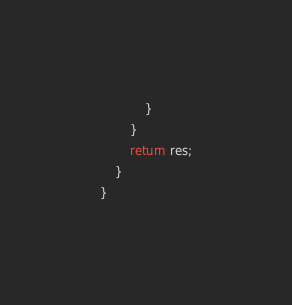Convert code to text. <code><loc_0><loc_0><loc_500><loc_500><_Java_>            }
        }
        return res;
    }
}
</code> 